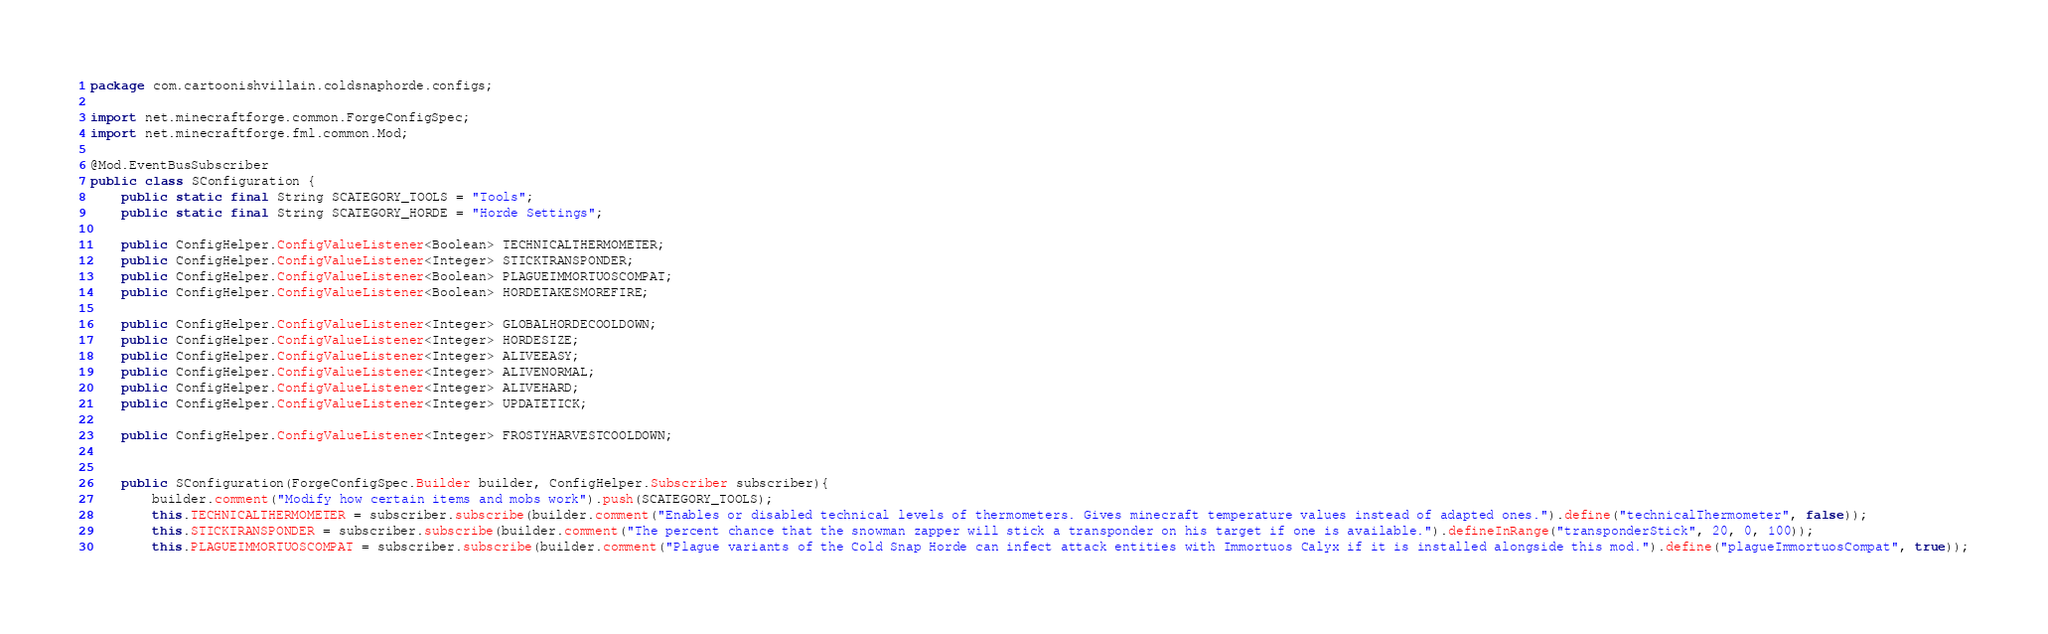Convert code to text. <code><loc_0><loc_0><loc_500><loc_500><_Java_>package com.cartoonishvillain.coldsnaphorde.configs;

import net.minecraftforge.common.ForgeConfigSpec;
import net.minecraftforge.fml.common.Mod;

@Mod.EventBusSubscriber
public class SConfiguration {
    public static final String SCATEGORY_TOOLS = "Tools";
    public static final String SCATEGORY_HORDE = "Horde Settings";

    public ConfigHelper.ConfigValueListener<Boolean> TECHNICALTHERMOMETER;
    public ConfigHelper.ConfigValueListener<Integer> STICKTRANSPONDER;
    public ConfigHelper.ConfigValueListener<Boolean> PLAGUEIMMORTUOSCOMPAT;
    public ConfigHelper.ConfigValueListener<Boolean> HORDETAKESMOREFIRE;

    public ConfigHelper.ConfigValueListener<Integer> GLOBALHORDECOOLDOWN;
    public ConfigHelper.ConfigValueListener<Integer> HORDESIZE;
    public ConfigHelper.ConfigValueListener<Integer> ALIVEEASY;
    public ConfigHelper.ConfigValueListener<Integer> ALIVENORMAL;
    public ConfigHelper.ConfigValueListener<Integer> ALIVEHARD;
    public ConfigHelper.ConfigValueListener<Integer> UPDATETICK;

    public ConfigHelper.ConfigValueListener<Integer> FROSTYHARVESTCOOLDOWN;


    public SConfiguration(ForgeConfigSpec.Builder builder, ConfigHelper.Subscriber subscriber){
        builder.comment("Modify how certain items and mobs work").push(SCATEGORY_TOOLS);
        this.TECHNICALTHERMOMETER = subscriber.subscribe(builder.comment("Enables or disabled technical levels of thermometers. Gives minecraft temperature values instead of adapted ones.").define("technicalThermometer", false));
        this.STICKTRANSPONDER = subscriber.subscribe(builder.comment("The percent chance that the snowman zapper will stick a transponder on his target if one is available.").defineInRange("transponderStick", 20, 0, 100));
        this.PLAGUEIMMORTUOSCOMPAT = subscriber.subscribe(builder.comment("Plague variants of the Cold Snap Horde can infect attack entities with Immortuos Calyx if it is installed alongside this mod.").define("plagueImmortuosCompat", true));</code> 